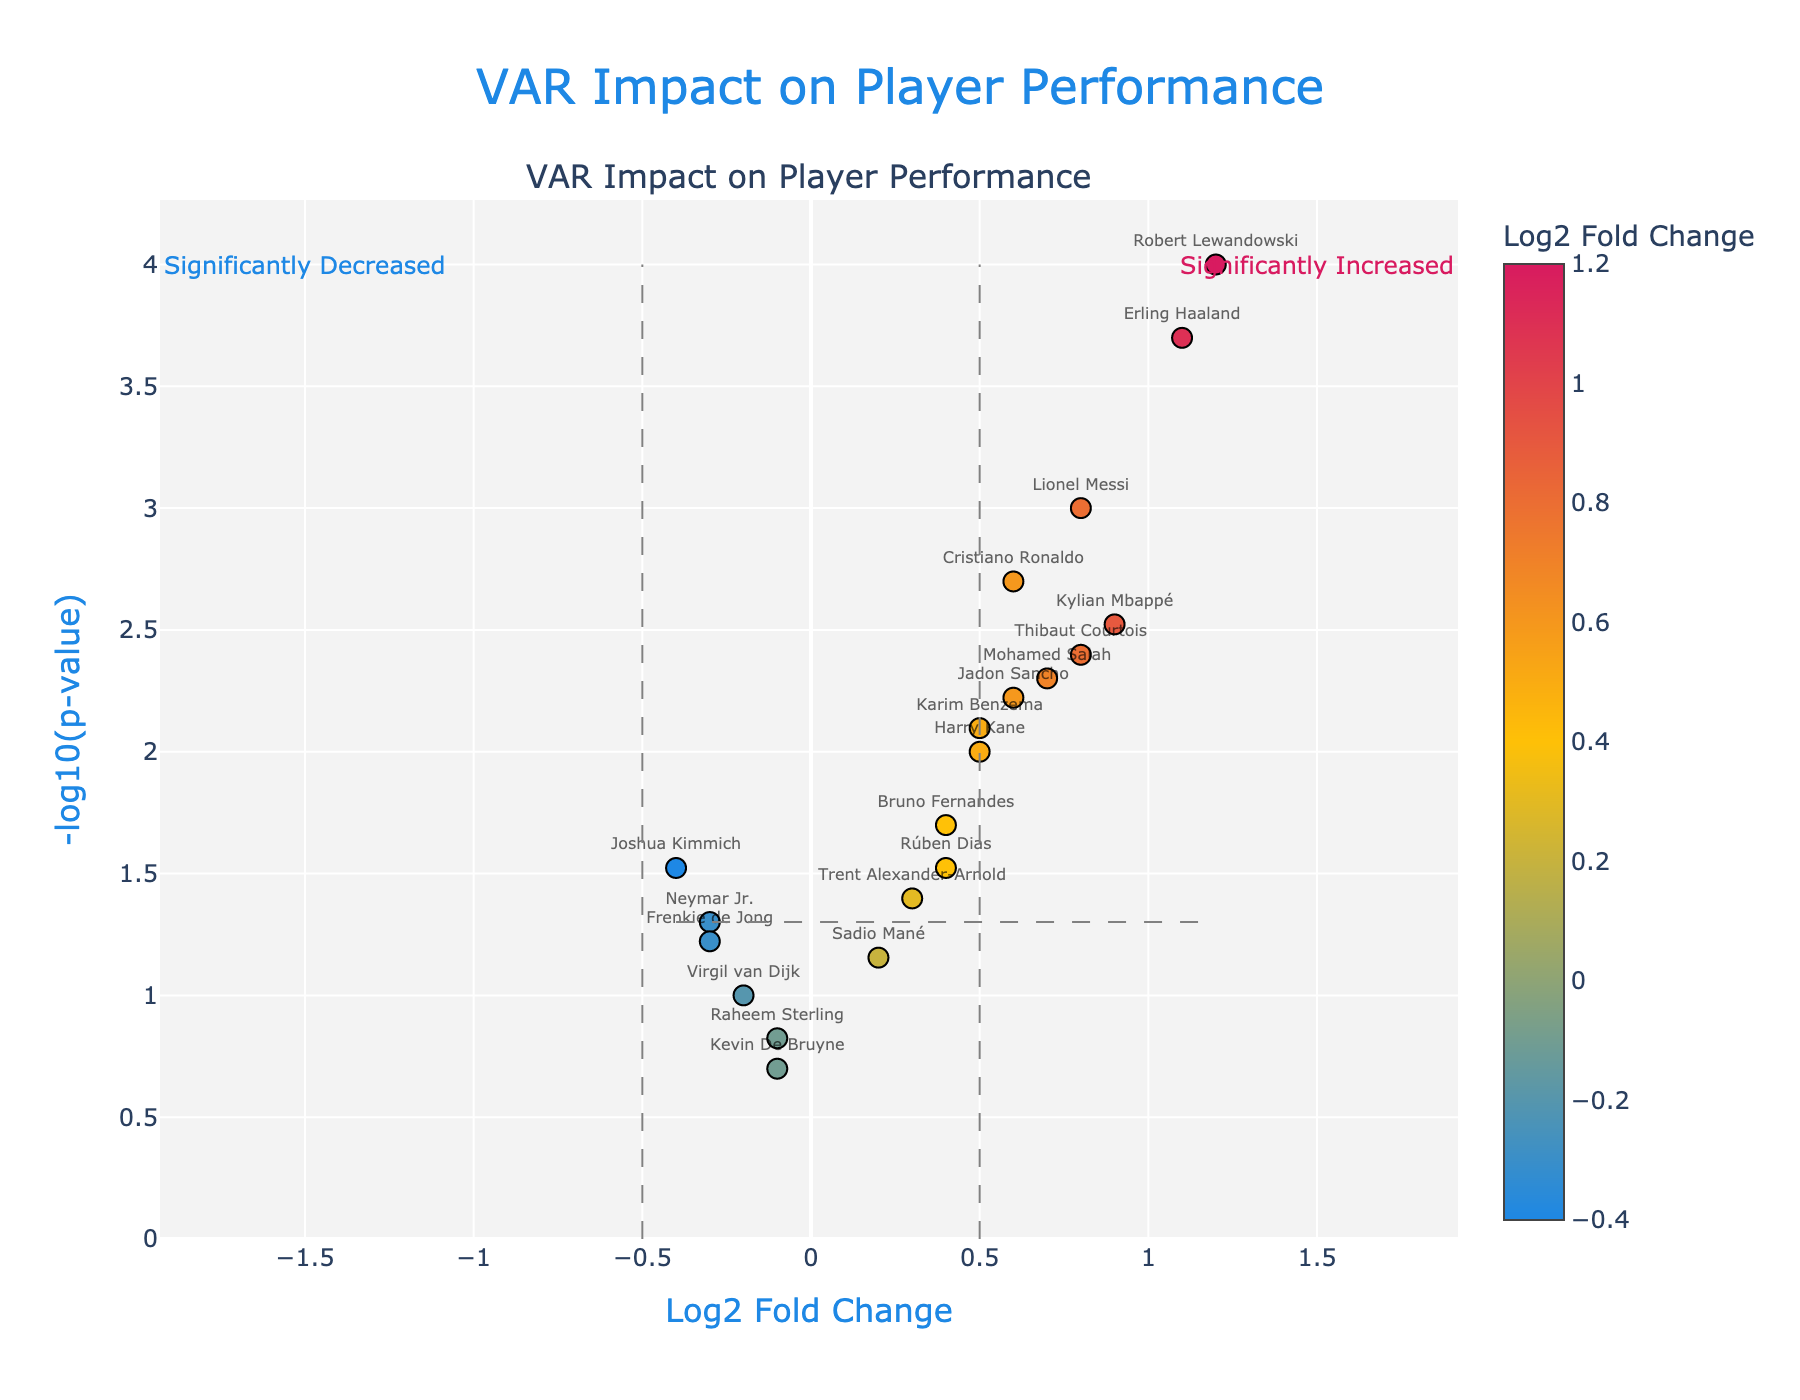What is the title of the plot? The title is located at the top of the figure. It reads "VAR Impact on Player Performance".
Answer: VAR Impact on Player Performance How many players showed a significantly increased performance after the implementation of VAR? A player is considered to have significantly increased performance if their Log2 Fold Change is greater than 0.5 and their p-value is less than 0.05. By looking at the volcano plot, there are 6 such players: Lionel Messi, Ronaldo, Lewandowski, Mbappé, Haaland, and Salah.
Answer: 6 Which player has the highest Log2 Fold Change and what is its value? Look at the x-axis to see the highest value. The highest Log2 Fold Change is 1.2, which belongs to Robert Lewandowski.
Answer: Robert Lewandowski, 1.2 Are there any players with a negative Log2 Fold Change and a p-value less than 0.05? Negative Log2 Fold Change values are on the left half of the plot. None of these points meet the criteria of having a p-value less than 0.05 because all negative values are aligned above the p-value threshold line.
Answer: No How is Neymar Jr.'s p-value compared to the threshold of 0.05? Neymar Jr. has a p-value of 0.05, which is right on the threshold line. Therefore, his value matches the threshold.
Answer: Equal to 0.05 Which player has the smallest p-value, and what does it imply about the statistical significance? By checking the y-axis for the highest points (since we take -log10 of the p-value), Robert Lewandowski has the smallest p-value of 0.0001. This indicates his performance change is highly statistically significant.
Answer: Robert Lewandowski, p-value of 0.0001 Which player with a positive Log2 Fold Change has the lowest significance (highest p-value)? For players with a positive Log2 Fold Change, locate the ones nearest to the x-axis (lowest value on y-axis). Trent Alexander-Arnold, with a p-value of 0.04, fits this description.
Answer: Trent Alexander-Arnold Who are the top 3 players with the highest -log10(p-value)? Check the highest points on the y-axis of the plot. The top 3 players are Robert Lewandowski, Erling Haaland, and Lionel Messi.
Answer: Robert Lewandowski, Erling Haaland, Lionel Messi Which player has a Log2 Fold Change closest to zero but still significant (p-value < 0.05)? Players close to zero are near the y-axis. Among them, Joshua Kimmich has a Log2 Fold Change of -0.4 with a p-value of 0.03.
Answer: Joshua Kimmich 